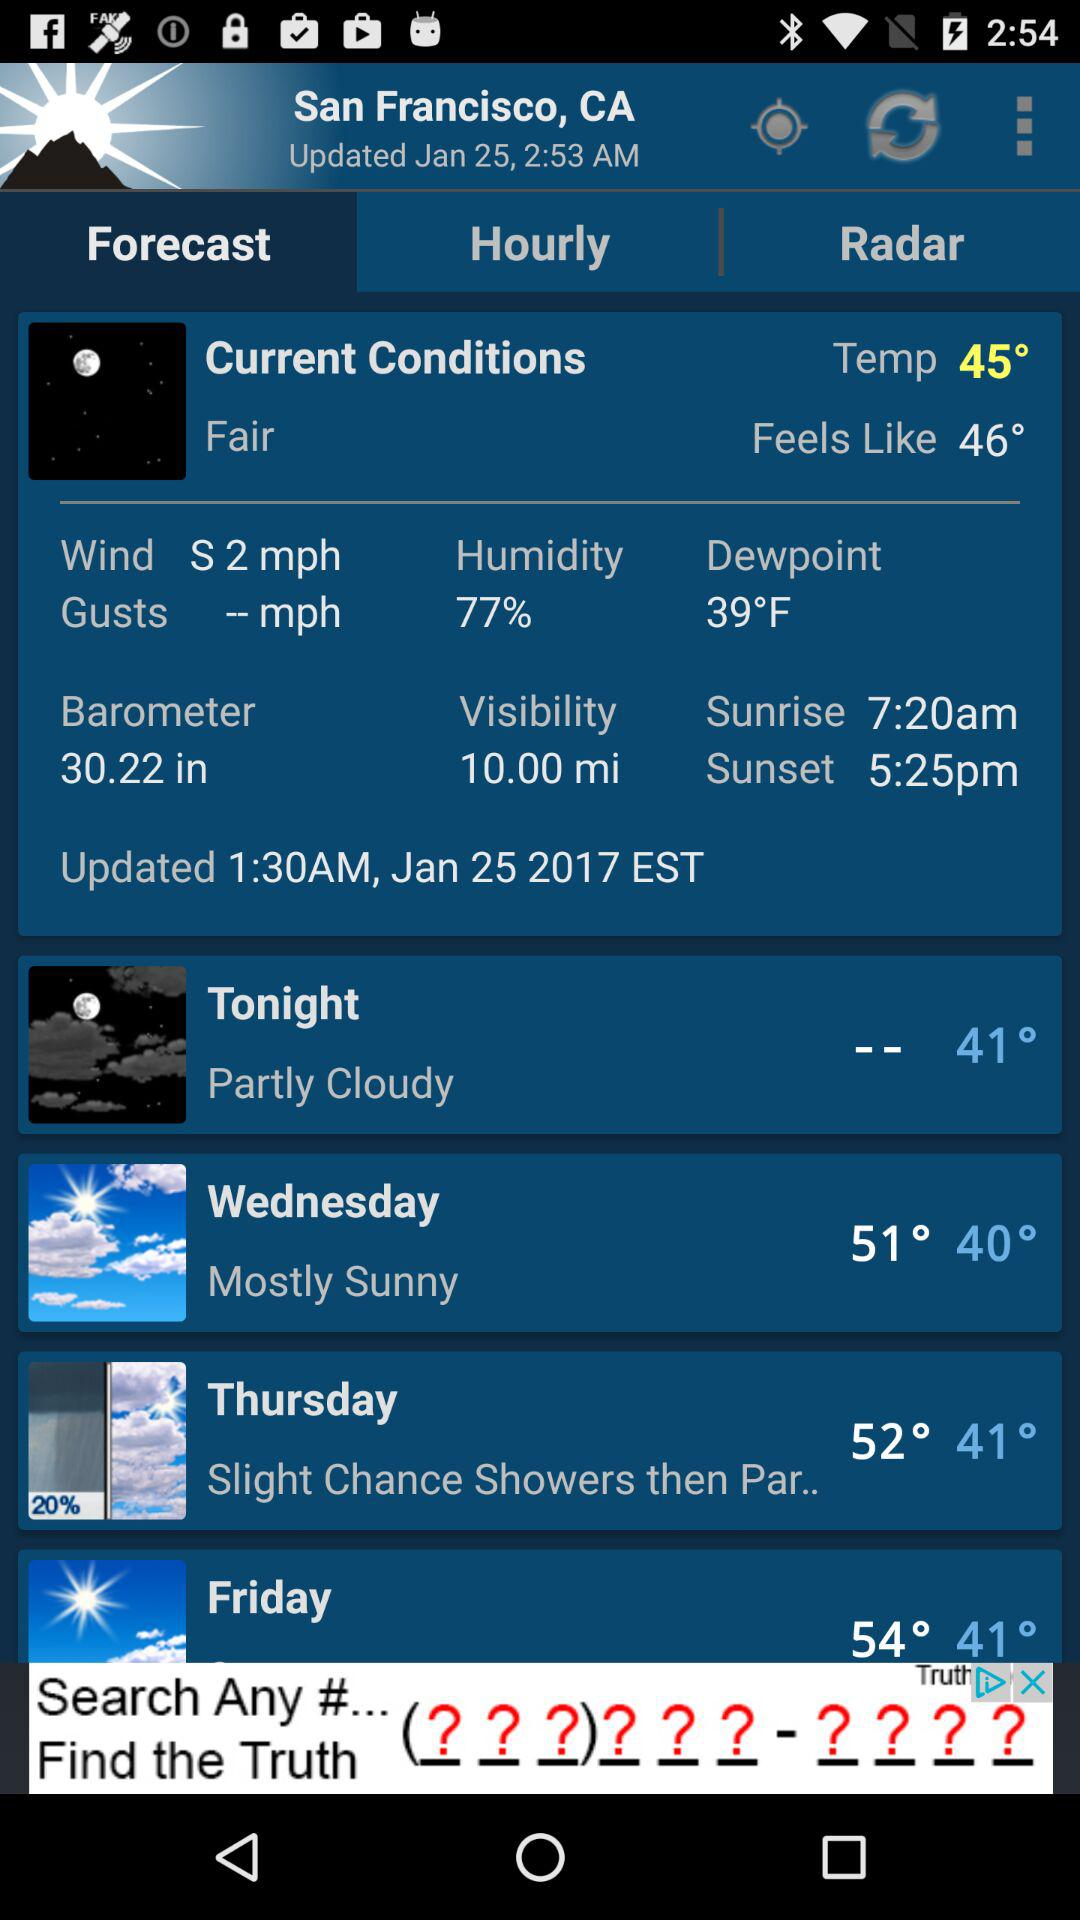What is the dewpoint? The dewpoint is 39 °F. 